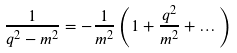<formula> <loc_0><loc_0><loc_500><loc_500>\frac { 1 } { q ^ { 2 } - m ^ { 2 } } = - \frac { 1 } { m ^ { 2 } } \left ( 1 + \frac { q ^ { 2 } } { m ^ { 2 } } + \dots \right )</formula> 